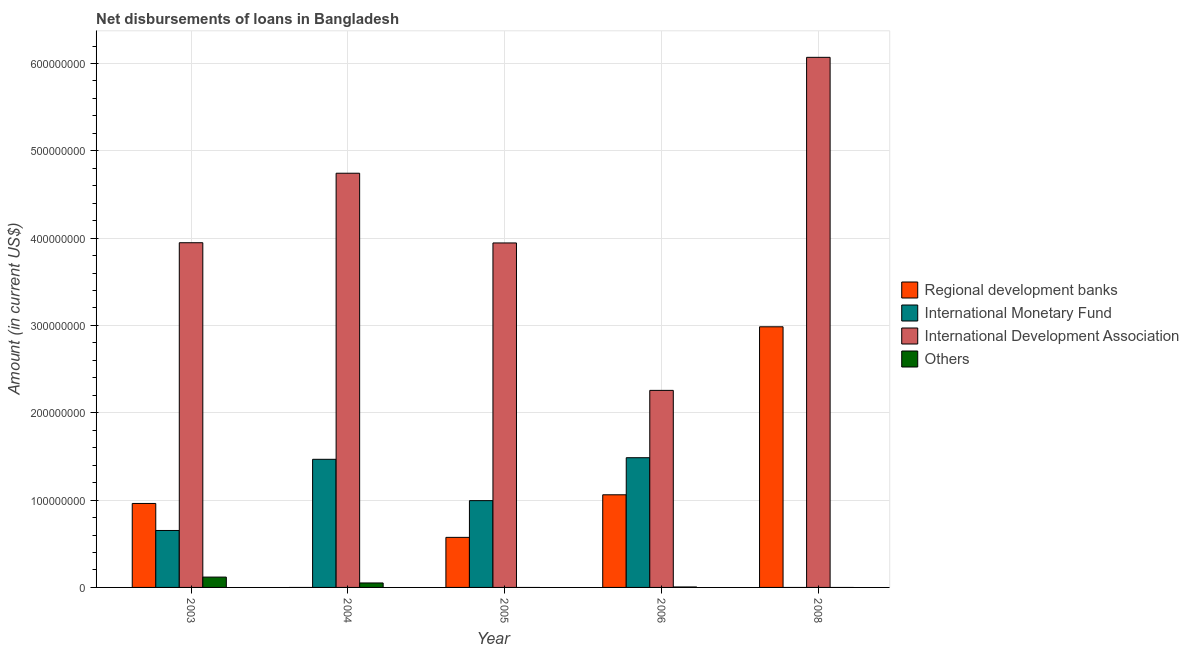How many different coloured bars are there?
Keep it short and to the point. 4. How many groups of bars are there?
Your response must be concise. 5. Are the number of bars per tick equal to the number of legend labels?
Make the answer very short. No. How many bars are there on the 1st tick from the right?
Your answer should be very brief. 2. What is the label of the 2nd group of bars from the left?
Provide a succinct answer. 2004. What is the amount of loan disimbursed by international monetary fund in 2006?
Make the answer very short. 1.49e+08. Across all years, what is the maximum amount of loan disimbursed by regional development banks?
Give a very brief answer. 2.98e+08. What is the total amount of loan disimbursed by regional development banks in the graph?
Ensure brevity in your answer.  5.58e+08. What is the difference between the amount of loan disimbursed by international development association in 2003 and that in 2008?
Provide a short and direct response. -2.12e+08. What is the difference between the amount of loan disimbursed by other organisations in 2005 and the amount of loan disimbursed by international development association in 2006?
Provide a short and direct response. -5.21e+05. What is the average amount of loan disimbursed by international development association per year?
Offer a very short reply. 4.19e+08. What is the ratio of the amount of loan disimbursed by international monetary fund in 2005 to that in 2006?
Keep it short and to the point. 0.67. Is the amount of loan disimbursed by international development association in 2003 less than that in 2004?
Your response must be concise. Yes. Is the difference between the amount of loan disimbursed by international development association in 2003 and 2008 greater than the difference between the amount of loan disimbursed by international monetary fund in 2003 and 2008?
Provide a succinct answer. No. What is the difference between the highest and the second highest amount of loan disimbursed by other organisations?
Ensure brevity in your answer.  6.72e+06. What is the difference between the highest and the lowest amount of loan disimbursed by regional development banks?
Keep it short and to the point. 2.98e+08. Is it the case that in every year, the sum of the amount of loan disimbursed by regional development banks and amount of loan disimbursed by international monetary fund is greater than the amount of loan disimbursed by international development association?
Provide a short and direct response. No. How many bars are there?
Offer a very short reply. 16. How many years are there in the graph?
Offer a very short reply. 5. What is the difference between two consecutive major ticks on the Y-axis?
Offer a terse response. 1.00e+08. Are the values on the major ticks of Y-axis written in scientific E-notation?
Your response must be concise. No. Does the graph contain any zero values?
Keep it short and to the point. Yes. Does the graph contain grids?
Make the answer very short. Yes. How are the legend labels stacked?
Your response must be concise. Vertical. What is the title of the graph?
Make the answer very short. Net disbursements of loans in Bangladesh. What is the label or title of the Y-axis?
Your answer should be compact. Amount (in current US$). What is the Amount (in current US$) in Regional development banks in 2003?
Your answer should be compact. 9.61e+07. What is the Amount (in current US$) of International Monetary Fund in 2003?
Offer a very short reply. 6.52e+07. What is the Amount (in current US$) of International Development Association in 2003?
Make the answer very short. 3.95e+08. What is the Amount (in current US$) in Others in 2003?
Offer a very short reply. 1.18e+07. What is the Amount (in current US$) in International Monetary Fund in 2004?
Give a very brief answer. 1.47e+08. What is the Amount (in current US$) of International Development Association in 2004?
Provide a short and direct response. 4.74e+08. What is the Amount (in current US$) in Others in 2004?
Your response must be concise. 5.12e+06. What is the Amount (in current US$) in Regional development banks in 2005?
Your answer should be compact. 5.73e+07. What is the Amount (in current US$) of International Monetary Fund in 2005?
Offer a terse response. 9.94e+07. What is the Amount (in current US$) of International Development Association in 2005?
Your answer should be very brief. 3.94e+08. What is the Amount (in current US$) in Others in 2005?
Your answer should be compact. 0. What is the Amount (in current US$) of Regional development banks in 2006?
Ensure brevity in your answer.  1.06e+08. What is the Amount (in current US$) in International Monetary Fund in 2006?
Provide a succinct answer. 1.49e+08. What is the Amount (in current US$) in International Development Association in 2006?
Your response must be concise. 2.26e+08. What is the Amount (in current US$) in Others in 2006?
Keep it short and to the point. 5.21e+05. What is the Amount (in current US$) in Regional development banks in 2008?
Provide a short and direct response. 2.98e+08. What is the Amount (in current US$) of International Monetary Fund in 2008?
Offer a terse response. 0. What is the Amount (in current US$) in International Development Association in 2008?
Keep it short and to the point. 6.07e+08. What is the Amount (in current US$) in Others in 2008?
Provide a short and direct response. 0. Across all years, what is the maximum Amount (in current US$) in Regional development banks?
Your response must be concise. 2.98e+08. Across all years, what is the maximum Amount (in current US$) of International Monetary Fund?
Offer a terse response. 1.49e+08. Across all years, what is the maximum Amount (in current US$) of International Development Association?
Provide a short and direct response. 6.07e+08. Across all years, what is the maximum Amount (in current US$) in Others?
Provide a short and direct response. 1.18e+07. Across all years, what is the minimum Amount (in current US$) of International Development Association?
Your answer should be very brief. 2.26e+08. Across all years, what is the minimum Amount (in current US$) of Others?
Your response must be concise. 0. What is the total Amount (in current US$) of Regional development banks in the graph?
Your answer should be compact. 5.58e+08. What is the total Amount (in current US$) in International Monetary Fund in the graph?
Your answer should be very brief. 4.60e+08. What is the total Amount (in current US$) in International Development Association in the graph?
Keep it short and to the point. 2.10e+09. What is the total Amount (in current US$) of Others in the graph?
Provide a short and direct response. 1.75e+07. What is the difference between the Amount (in current US$) of International Monetary Fund in 2003 and that in 2004?
Ensure brevity in your answer.  -8.15e+07. What is the difference between the Amount (in current US$) in International Development Association in 2003 and that in 2004?
Your answer should be compact. -7.96e+07. What is the difference between the Amount (in current US$) of Others in 2003 and that in 2004?
Your response must be concise. 6.72e+06. What is the difference between the Amount (in current US$) in Regional development banks in 2003 and that in 2005?
Your response must be concise. 3.88e+07. What is the difference between the Amount (in current US$) in International Monetary Fund in 2003 and that in 2005?
Your answer should be very brief. -3.42e+07. What is the difference between the Amount (in current US$) in International Development Association in 2003 and that in 2005?
Your response must be concise. 2.41e+05. What is the difference between the Amount (in current US$) in Regional development banks in 2003 and that in 2006?
Your response must be concise. -9.94e+06. What is the difference between the Amount (in current US$) of International Monetary Fund in 2003 and that in 2006?
Your answer should be compact. -8.33e+07. What is the difference between the Amount (in current US$) in International Development Association in 2003 and that in 2006?
Offer a very short reply. 1.69e+08. What is the difference between the Amount (in current US$) in Others in 2003 and that in 2006?
Offer a terse response. 1.13e+07. What is the difference between the Amount (in current US$) in Regional development banks in 2003 and that in 2008?
Ensure brevity in your answer.  -2.02e+08. What is the difference between the Amount (in current US$) in International Development Association in 2003 and that in 2008?
Your answer should be compact. -2.12e+08. What is the difference between the Amount (in current US$) in International Monetary Fund in 2004 and that in 2005?
Make the answer very short. 4.73e+07. What is the difference between the Amount (in current US$) in International Development Association in 2004 and that in 2005?
Keep it short and to the point. 7.98e+07. What is the difference between the Amount (in current US$) of International Monetary Fund in 2004 and that in 2006?
Provide a succinct answer. -1.82e+06. What is the difference between the Amount (in current US$) in International Development Association in 2004 and that in 2006?
Ensure brevity in your answer.  2.49e+08. What is the difference between the Amount (in current US$) in Others in 2004 and that in 2006?
Your answer should be very brief. 4.60e+06. What is the difference between the Amount (in current US$) of International Development Association in 2004 and that in 2008?
Keep it short and to the point. -1.33e+08. What is the difference between the Amount (in current US$) in Regional development banks in 2005 and that in 2006?
Your response must be concise. -4.88e+07. What is the difference between the Amount (in current US$) in International Monetary Fund in 2005 and that in 2006?
Provide a succinct answer. -4.91e+07. What is the difference between the Amount (in current US$) of International Development Association in 2005 and that in 2006?
Provide a short and direct response. 1.69e+08. What is the difference between the Amount (in current US$) of Regional development banks in 2005 and that in 2008?
Give a very brief answer. -2.41e+08. What is the difference between the Amount (in current US$) of International Development Association in 2005 and that in 2008?
Make the answer very short. -2.13e+08. What is the difference between the Amount (in current US$) in Regional development banks in 2006 and that in 2008?
Ensure brevity in your answer.  -1.92e+08. What is the difference between the Amount (in current US$) of International Development Association in 2006 and that in 2008?
Provide a succinct answer. -3.81e+08. What is the difference between the Amount (in current US$) of Regional development banks in 2003 and the Amount (in current US$) of International Monetary Fund in 2004?
Your answer should be very brief. -5.06e+07. What is the difference between the Amount (in current US$) in Regional development banks in 2003 and the Amount (in current US$) in International Development Association in 2004?
Your answer should be very brief. -3.78e+08. What is the difference between the Amount (in current US$) of Regional development banks in 2003 and the Amount (in current US$) of Others in 2004?
Provide a short and direct response. 9.10e+07. What is the difference between the Amount (in current US$) in International Monetary Fund in 2003 and the Amount (in current US$) in International Development Association in 2004?
Ensure brevity in your answer.  -4.09e+08. What is the difference between the Amount (in current US$) in International Monetary Fund in 2003 and the Amount (in current US$) in Others in 2004?
Provide a succinct answer. 6.01e+07. What is the difference between the Amount (in current US$) of International Development Association in 2003 and the Amount (in current US$) of Others in 2004?
Ensure brevity in your answer.  3.90e+08. What is the difference between the Amount (in current US$) of Regional development banks in 2003 and the Amount (in current US$) of International Monetary Fund in 2005?
Give a very brief answer. -3.25e+06. What is the difference between the Amount (in current US$) in Regional development banks in 2003 and the Amount (in current US$) in International Development Association in 2005?
Give a very brief answer. -2.98e+08. What is the difference between the Amount (in current US$) in International Monetary Fund in 2003 and the Amount (in current US$) in International Development Association in 2005?
Your response must be concise. -3.29e+08. What is the difference between the Amount (in current US$) in Regional development banks in 2003 and the Amount (in current US$) in International Monetary Fund in 2006?
Your answer should be very brief. -5.24e+07. What is the difference between the Amount (in current US$) of Regional development banks in 2003 and the Amount (in current US$) of International Development Association in 2006?
Your answer should be compact. -1.30e+08. What is the difference between the Amount (in current US$) in Regional development banks in 2003 and the Amount (in current US$) in Others in 2006?
Provide a short and direct response. 9.56e+07. What is the difference between the Amount (in current US$) of International Monetary Fund in 2003 and the Amount (in current US$) of International Development Association in 2006?
Offer a very short reply. -1.60e+08. What is the difference between the Amount (in current US$) of International Monetary Fund in 2003 and the Amount (in current US$) of Others in 2006?
Your answer should be compact. 6.47e+07. What is the difference between the Amount (in current US$) in International Development Association in 2003 and the Amount (in current US$) in Others in 2006?
Provide a short and direct response. 3.94e+08. What is the difference between the Amount (in current US$) of Regional development banks in 2003 and the Amount (in current US$) of International Development Association in 2008?
Your answer should be compact. -5.11e+08. What is the difference between the Amount (in current US$) in International Monetary Fund in 2003 and the Amount (in current US$) in International Development Association in 2008?
Keep it short and to the point. -5.42e+08. What is the difference between the Amount (in current US$) in International Monetary Fund in 2004 and the Amount (in current US$) in International Development Association in 2005?
Provide a short and direct response. -2.48e+08. What is the difference between the Amount (in current US$) in International Monetary Fund in 2004 and the Amount (in current US$) in International Development Association in 2006?
Provide a short and direct response. -7.89e+07. What is the difference between the Amount (in current US$) of International Monetary Fund in 2004 and the Amount (in current US$) of Others in 2006?
Your response must be concise. 1.46e+08. What is the difference between the Amount (in current US$) of International Development Association in 2004 and the Amount (in current US$) of Others in 2006?
Your answer should be compact. 4.74e+08. What is the difference between the Amount (in current US$) of International Monetary Fund in 2004 and the Amount (in current US$) of International Development Association in 2008?
Provide a short and direct response. -4.60e+08. What is the difference between the Amount (in current US$) in Regional development banks in 2005 and the Amount (in current US$) in International Monetary Fund in 2006?
Give a very brief answer. -9.12e+07. What is the difference between the Amount (in current US$) of Regional development banks in 2005 and the Amount (in current US$) of International Development Association in 2006?
Keep it short and to the point. -1.68e+08. What is the difference between the Amount (in current US$) in Regional development banks in 2005 and the Amount (in current US$) in Others in 2006?
Your answer should be very brief. 5.68e+07. What is the difference between the Amount (in current US$) in International Monetary Fund in 2005 and the Amount (in current US$) in International Development Association in 2006?
Keep it short and to the point. -1.26e+08. What is the difference between the Amount (in current US$) in International Monetary Fund in 2005 and the Amount (in current US$) in Others in 2006?
Give a very brief answer. 9.89e+07. What is the difference between the Amount (in current US$) in International Development Association in 2005 and the Amount (in current US$) in Others in 2006?
Offer a terse response. 3.94e+08. What is the difference between the Amount (in current US$) of Regional development banks in 2005 and the Amount (in current US$) of International Development Association in 2008?
Provide a short and direct response. -5.50e+08. What is the difference between the Amount (in current US$) of International Monetary Fund in 2005 and the Amount (in current US$) of International Development Association in 2008?
Your answer should be very brief. -5.08e+08. What is the difference between the Amount (in current US$) in Regional development banks in 2006 and the Amount (in current US$) in International Development Association in 2008?
Offer a terse response. -5.01e+08. What is the difference between the Amount (in current US$) in International Monetary Fund in 2006 and the Amount (in current US$) in International Development Association in 2008?
Provide a succinct answer. -4.59e+08. What is the average Amount (in current US$) of Regional development banks per year?
Provide a short and direct response. 1.12e+08. What is the average Amount (in current US$) in International Monetary Fund per year?
Your answer should be very brief. 9.20e+07. What is the average Amount (in current US$) in International Development Association per year?
Your response must be concise. 4.19e+08. What is the average Amount (in current US$) in Others per year?
Provide a short and direct response. 3.50e+06. In the year 2003, what is the difference between the Amount (in current US$) of Regional development banks and Amount (in current US$) of International Monetary Fund?
Keep it short and to the point. 3.09e+07. In the year 2003, what is the difference between the Amount (in current US$) in Regional development banks and Amount (in current US$) in International Development Association?
Make the answer very short. -2.99e+08. In the year 2003, what is the difference between the Amount (in current US$) in Regional development banks and Amount (in current US$) in Others?
Keep it short and to the point. 8.43e+07. In the year 2003, what is the difference between the Amount (in current US$) of International Monetary Fund and Amount (in current US$) of International Development Association?
Offer a very short reply. -3.30e+08. In the year 2003, what is the difference between the Amount (in current US$) in International Monetary Fund and Amount (in current US$) in Others?
Offer a terse response. 5.34e+07. In the year 2003, what is the difference between the Amount (in current US$) in International Development Association and Amount (in current US$) in Others?
Your response must be concise. 3.83e+08. In the year 2004, what is the difference between the Amount (in current US$) in International Monetary Fund and Amount (in current US$) in International Development Association?
Provide a succinct answer. -3.28e+08. In the year 2004, what is the difference between the Amount (in current US$) in International Monetary Fund and Amount (in current US$) in Others?
Provide a succinct answer. 1.42e+08. In the year 2004, what is the difference between the Amount (in current US$) in International Development Association and Amount (in current US$) in Others?
Give a very brief answer. 4.69e+08. In the year 2005, what is the difference between the Amount (in current US$) of Regional development banks and Amount (in current US$) of International Monetary Fund?
Provide a succinct answer. -4.21e+07. In the year 2005, what is the difference between the Amount (in current US$) of Regional development banks and Amount (in current US$) of International Development Association?
Offer a terse response. -3.37e+08. In the year 2005, what is the difference between the Amount (in current US$) of International Monetary Fund and Amount (in current US$) of International Development Association?
Provide a succinct answer. -2.95e+08. In the year 2006, what is the difference between the Amount (in current US$) in Regional development banks and Amount (in current US$) in International Monetary Fund?
Your response must be concise. -4.24e+07. In the year 2006, what is the difference between the Amount (in current US$) in Regional development banks and Amount (in current US$) in International Development Association?
Ensure brevity in your answer.  -1.20e+08. In the year 2006, what is the difference between the Amount (in current US$) of Regional development banks and Amount (in current US$) of Others?
Offer a very short reply. 1.06e+08. In the year 2006, what is the difference between the Amount (in current US$) of International Monetary Fund and Amount (in current US$) of International Development Association?
Your answer should be compact. -7.71e+07. In the year 2006, what is the difference between the Amount (in current US$) in International Monetary Fund and Amount (in current US$) in Others?
Keep it short and to the point. 1.48e+08. In the year 2006, what is the difference between the Amount (in current US$) of International Development Association and Amount (in current US$) of Others?
Provide a succinct answer. 2.25e+08. In the year 2008, what is the difference between the Amount (in current US$) in Regional development banks and Amount (in current US$) in International Development Association?
Offer a terse response. -3.09e+08. What is the ratio of the Amount (in current US$) in International Monetary Fund in 2003 to that in 2004?
Make the answer very short. 0.44. What is the ratio of the Amount (in current US$) in International Development Association in 2003 to that in 2004?
Your answer should be compact. 0.83. What is the ratio of the Amount (in current US$) of Others in 2003 to that in 2004?
Your response must be concise. 2.31. What is the ratio of the Amount (in current US$) in Regional development banks in 2003 to that in 2005?
Your response must be concise. 1.68. What is the ratio of the Amount (in current US$) in International Monetary Fund in 2003 to that in 2005?
Offer a very short reply. 0.66. What is the ratio of the Amount (in current US$) of Regional development banks in 2003 to that in 2006?
Your answer should be compact. 0.91. What is the ratio of the Amount (in current US$) in International Monetary Fund in 2003 to that in 2006?
Keep it short and to the point. 0.44. What is the ratio of the Amount (in current US$) in International Development Association in 2003 to that in 2006?
Offer a very short reply. 1.75. What is the ratio of the Amount (in current US$) in Others in 2003 to that in 2006?
Your answer should be very brief. 22.72. What is the ratio of the Amount (in current US$) of Regional development banks in 2003 to that in 2008?
Ensure brevity in your answer.  0.32. What is the ratio of the Amount (in current US$) of International Development Association in 2003 to that in 2008?
Give a very brief answer. 0.65. What is the ratio of the Amount (in current US$) of International Monetary Fund in 2004 to that in 2005?
Keep it short and to the point. 1.48. What is the ratio of the Amount (in current US$) in International Development Association in 2004 to that in 2005?
Offer a terse response. 1.2. What is the ratio of the Amount (in current US$) of International Monetary Fund in 2004 to that in 2006?
Your response must be concise. 0.99. What is the ratio of the Amount (in current US$) in International Development Association in 2004 to that in 2006?
Keep it short and to the point. 2.1. What is the ratio of the Amount (in current US$) in Others in 2004 to that in 2006?
Provide a short and direct response. 9.82. What is the ratio of the Amount (in current US$) in International Development Association in 2004 to that in 2008?
Give a very brief answer. 0.78. What is the ratio of the Amount (in current US$) in Regional development banks in 2005 to that in 2006?
Offer a very short reply. 0.54. What is the ratio of the Amount (in current US$) in International Monetary Fund in 2005 to that in 2006?
Offer a very short reply. 0.67. What is the ratio of the Amount (in current US$) in International Development Association in 2005 to that in 2006?
Give a very brief answer. 1.75. What is the ratio of the Amount (in current US$) in Regional development banks in 2005 to that in 2008?
Give a very brief answer. 0.19. What is the ratio of the Amount (in current US$) of International Development Association in 2005 to that in 2008?
Your response must be concise. 0.65. What is the ratio of the Amount (in current US$) in Regional development banks in 2006 to that in 2008?
Your answer should be compact. 0.36. What is the ratio of the Amount (in current US$) of International Development Association in 2006 to that in 2008?
Your answer should be very brief. 0.37. What is the difference between the highest and the second highest Amount (in current US$) of Regional development banks?
Ensure brevity in your answer.  1.92e+08. What is the difference between the highest and the second highest Amount (in current US$) in International Monetary Fund?
Your response must be concise. 1.82e+06. What is the difference between the highest and the second highest Amount (in current US$) of International Development Association?
Give a very brief answer. 1.33e+08. What is the difference between the highest and the second highest Amount (in current US$) in Others?
Provide a succinct answer. 6.72e+06. What is the difference between the highest and the lowest Amount (in current US$) of Regional development banks?
Keep it short and to the point. 2.98e+08. What is the difference between the highest and the lowest Amount (in current US$) in International Monetary Fund?
Provide a succinct answer. 1.49e+08. What is the difference between the highest and the lowest Amount (in current US$) in International Development Association?
Give a very brief answer. 3.81e+08. What is the difference between the highest and the lowest Amount (in current US$) in Others?
Your response must be concise. 1.18e+07. 